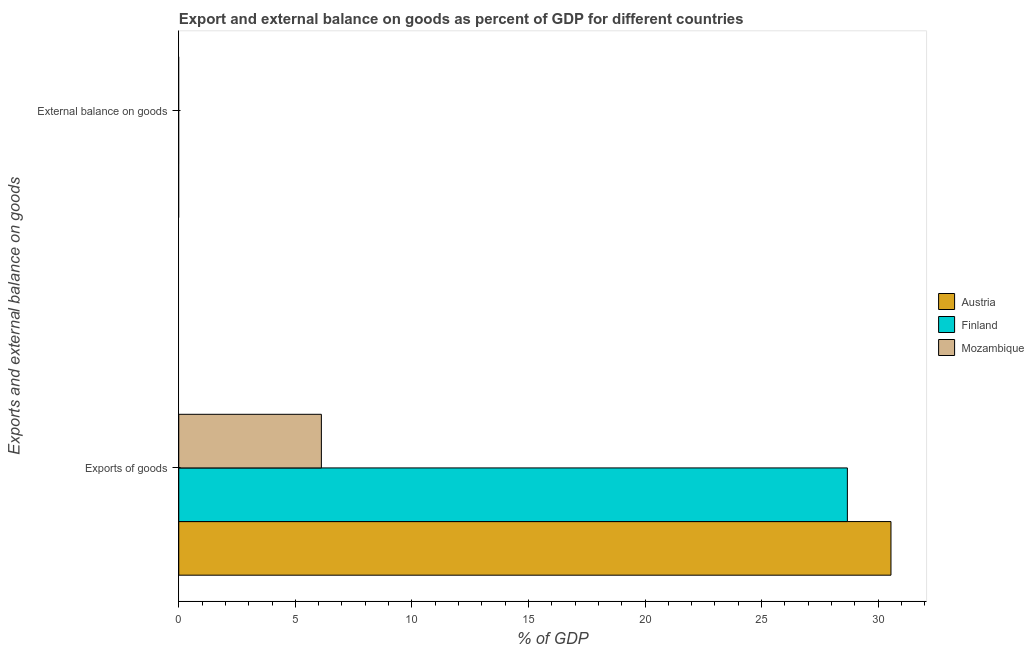How many different coloured bars are there?
Your response must be concise. 3. Are the number of bars on each tick of the Y-axis equal?
Your answer should be compact. No. What is the label of the 2nd group of bars from the top?
Ensure brevity in your answer.  Exports of goods. What is the export of goods as percentage of gdp in Mozambique?
Provide a succinct answer. 6.12. Across all countries, what is the maximum export of goods as percentage of gdp?
Offer a terse response. 30.55. Across all countries, what is the minimum export of goods as percentage of gdp?
Offer a terse response. 6.12. What is the total export of goods as percentage of gdp in the graph?
Ensure brevity in your answer.  65.35. What is the difference between the export of goods as percentage of gdp in Austria and that in Finland?
Your response must be concise. 1.87. What is the difference between the export of goods as percentage of gdp in Mozambique and the external balance on goods as percentage of gdp in Finland?
Ensure brevity in your answer.  6.12. What is the average export of goods as percentage of gdp per country?
Offer a very short reply. 21.78. What is the ratio of the export of goods as percentage of gdp in Austria to that in Finland?
Make the answer very short. 1.07. Are all the bars in the graph horizontal?
Give a very brief answer. Yes. Are the values on the major ticks of X-axis written in scientific E-notation?
Ensure brevity in your answer.  No. Does the graph contain any zero values?
Make the answer very short. Yes. Does the graph contain grids?
Provide a short and direct response. No. Where does the legend appear in the graph?
Your answer should be compact. Center right. What is the title of the graph?
Offer a terse response. Export and external balance on goods as percent of GDP for different countries. What is the label or title of the X-axis?
Provide a short and direct response. % of GDP. What is the label or title of the Y-axis?
Your answer should be very brief. Exports and external balance on goods. What is the % of GDP of Austria in Exports of goods?
Make the answer very short. 30.55. What is the % of GDP of Finland in Exports of goods?
Ensure brevity in your answer.  28.68. What is the % of GDP of Mozambique in Exports of goods?
Your response must be concise. 6.12. Across all Exports and external balance on goods, what is the maximum % of GDP in Austria?
Keep it short and to the point. 30.55. Across all Exports and external balance on goods, what is the maximum % of GDP in Finland?
Offer a terse response. 28.68. Across all Exports and external balance on goods, what is the maximum % of GDP of Mozambique?
Your answer should be very brief. 6.12. Across all Exports and external balance on goods, what is the minimum % of GDP in Austria?
Your answer should be compact. 0. Across all Exports and external balance on goods, what is the minimum % of GDP of Finland?
Provide a succinct answer. 0. What is the total % of GDP of Austria in the graph?
Give a very brief answer. 30.55. What is the total % of GDP in Finland in the graph?
Provide a succinct answer. 28.68. What is the total % of GDP of Mozambique in the graph?
Offer a terse response. 6.12. What is the average % of GDP in Austria per Exports and external balance on goods?
Offer a very short reply. 15.28. What is the average % of GDP in Finland per Exports and external balance on goods?
Your answer should be very brief. 14.34. What is the average % of GDP of Mozambique per Exports and external balance on goods?
Give a very brief answer. 3.06. What is the difference between the % of GDP of Austria and % of GDP of Finland in Exports of goods?
Your answer should be compact. 1.87. What is the difference between the % of GDP in Austria and % of GDP in Mozambique in Exports of goods?
Your answer should be very brief. 24.43. What is the difference between the % of GDP in Finland and % of GDP in Mozambique in Exports of goods?
Offer a very short reply. 22.56. What is the difference between the highest and the lowest % of GDP of Austria?
Ensure brevity in your answer.  30.55. What is the difference between the highest and the lowest % of GDP of Finland?
Your response must be concise. 28.68. What is the difference between the highest and the lowest % of GDP in Mozambique?
Offer a terse response. 6.12. 